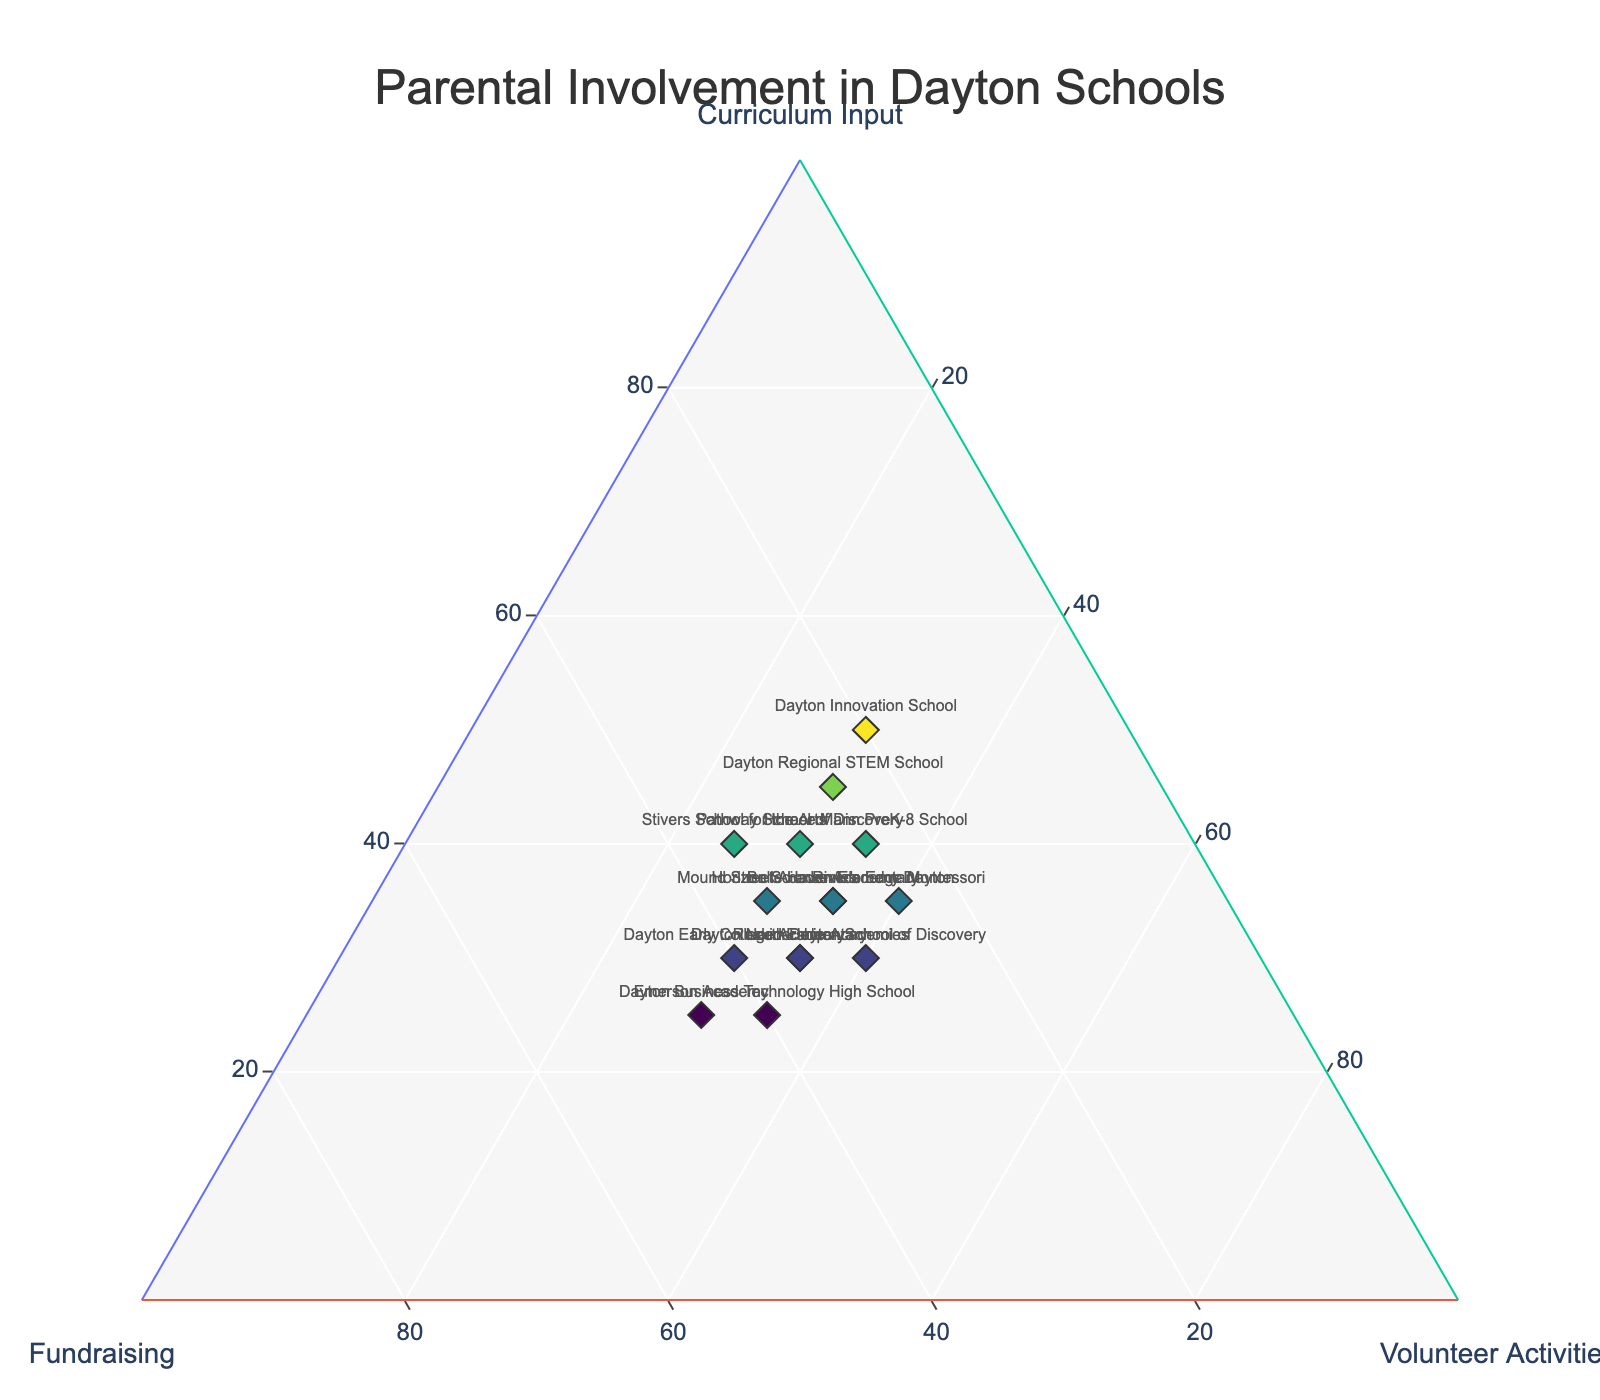What's the title of the figure? The title is usually displayed at the top of the figure. By reading it, we can understand the main subject or purpose of the plot.
Answer: Parental Involvement in Dayton Schools How many schools are represented in the figure? Each data point represents one school. By counting the data points, we can determine the number of schools represented.
Answer: 15 Which school has the highest parental involvement in curriculum input? Look for the data point with the highest value on the 'Curriculum Input' axis. The hover information can also confirm the exact value.
Answer: Dayton Innovation School Which schools have equal parental involvement in volunteer activities? Find data points with the same value on the 'Volunteer Activities' axis. Cross-reference with the school names to identify them.
Answer: Horizon Science Academy Dayton and Belle Haven Elementary; Dayton Early College Academy, Emerson Academy, and Ruskin Elementary For Dayton Early College Academy, what are the values for curriculum input, fundraising, and volunteer activities? Locate the data point labeled 'Dayton Early College Academy' and read off the corresponding values from the hover information or the plot itself.
Answer: Curriculum Input: 30, Fundraising: 40, Volunteer Activities: 30 What is the average value of parental involvement in fundraising across all schools? Sum all the fundraising values and divide by the number of schools to get the average. (35 + 40 + 30 + 25 + 45 + 35 + 35 + 30 + 30 + 20 + 25 + 40 + 35 + 30 + 25) / 15 = 34.67
Answer: 34.67 How does the parental involvement in volunteer activities for River's Edge Montessori compare with others? Look at the value for 'Volunteer Activities' for River's Edge Montessori and compare it with other values on the same axis.
Answer: Higher than most other schools Which school shows the most balanced parental involvement across all three activities? Look for the data point closest to the center of the triangle, indicating relatively equal values in all three categories.
Answer: Horace Mann PreK-8 School What's the difference in fundraising involvement between Dayton Leadership Academies and Dayton Business Technology High School? Subtract the fundraising value of Dayton Business Technology High School from that of Dayton Leadership Academies. 35 - 40 = -5
Answer: -5 How does parental involvement in curriculum input at Dayton Regional STEM School compare to Stivers School for the Arts? Compare the 'Curriculum Input' values for both schools. 45 (Dayton Regional STEM School) vs. 40 (Stivers School for the Arts)
Answer: Higher at Dayton Regional STEM School 